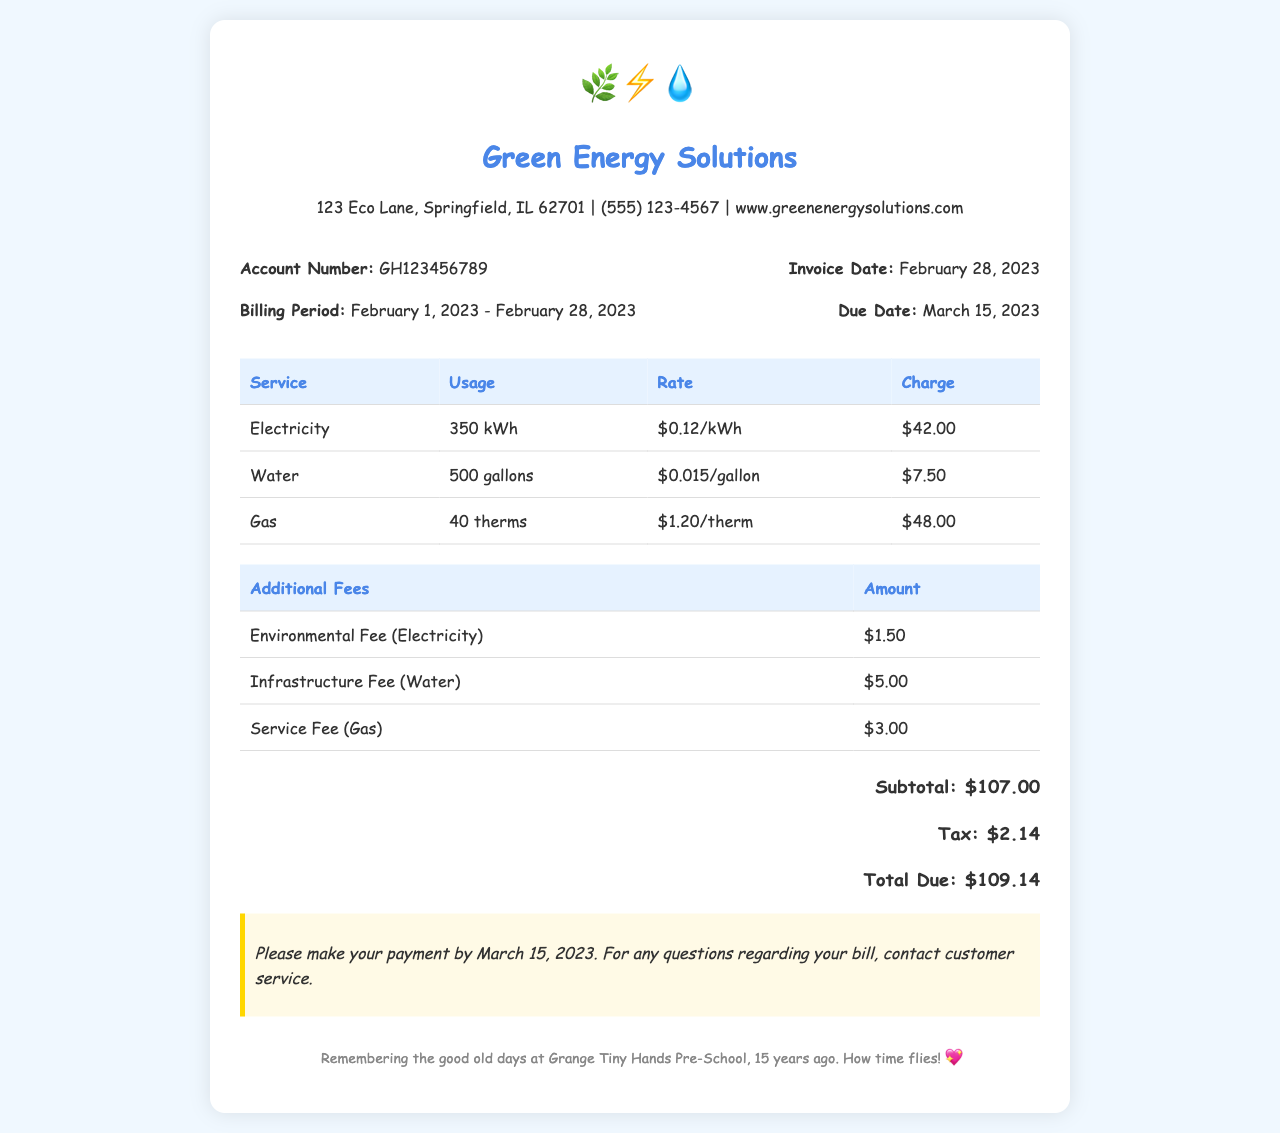What is the account number? The account number is listed in the document as GH123456789.
Answer: GH123456789 What is the billing period? The billing period is indicated as February 1, 2023 - February 28, 2023.
Answer: February 1, 2023 - February 28, 2023 How much was charged for electricity? The charge for electricity is explicitly stated in the document as $42.00.
Answer: $42.00 What is the total amount due? The total amount due is the sum of charges and taxes, stated in the document as $109.14.
Answer: $109.14 What is the due date for payment? The due date for payment is mentioned as March 15, 2023.
Answer: March 15, 2023 How much is the environmental fee for electricity? The environmental fee for electricity is detailed in the document as $1.50.
Answer: $1.50 What is the usage of gas in therms? The document specifies the gas usage as 40 therms.
Answer: 40 therms What does the note at the bottom refer to? The note references making a payment by the due date and contacting customer service with questions.
Answer: Payment and customer service What was the tax amount? The tax amount listed in the document is $2.14.
Answer: $2.14 